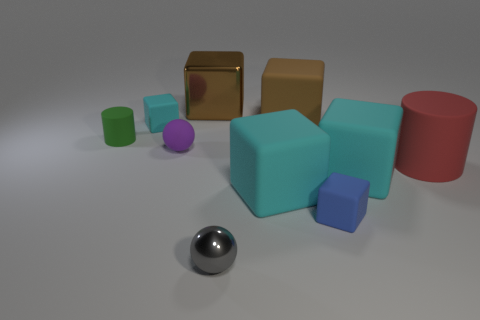Subtract all purple spheres. How many spheres are left? 1 Subtract all tiny blocks. How many blocks are left? 4 Subtract 0 cyan cylinders. How many objects are left? 10 Subtract all balls. How many objects are left? 8 Subtract 6 cubes. How many cubes are left? 0 Subtract all brown cubes. Subtract all blue balls. How many cubes are left? 4 Subtract all green cubes. How many blue balls are left? 0 Subtract all large cyan matte blocks. Subtract all small rubber objects. How many objects are left? 4 Add 7 big rubber cylinders. How many big rubber cylinders are left? 8 Add 3 rubber cylinders. How many rubber cylinders exist? 5 